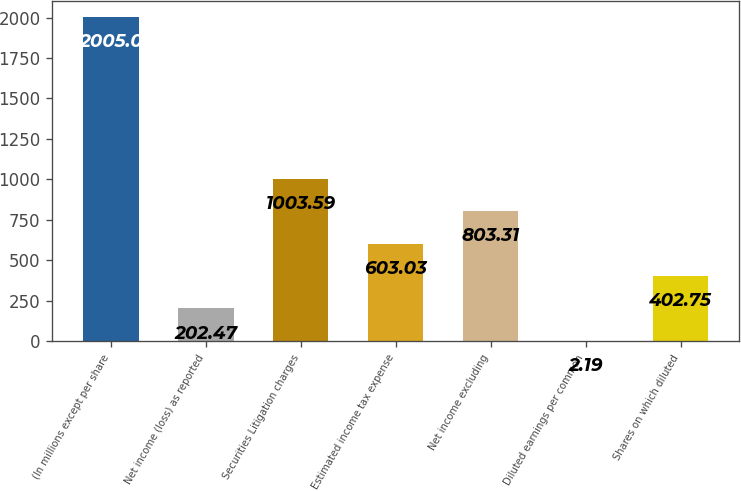Convert chart. <chart><loc_0><loc_0><loc_500><loc_500><bar_chart><fcel>(In millions except per share<fcel>Net income (loss) as reported<fcel>Securities Litigation charges<fcel>Estimated income tax expense<fcel>Net income excluding<fcel>Diluted earnings per common<fcel>Shares on which diluted<nl><fcel>2005<fcel>202.47<fcel>1003.59<fcel>603.03<fcel>803.31<fcel>2.19<fcel>402.75<nl></chart> 